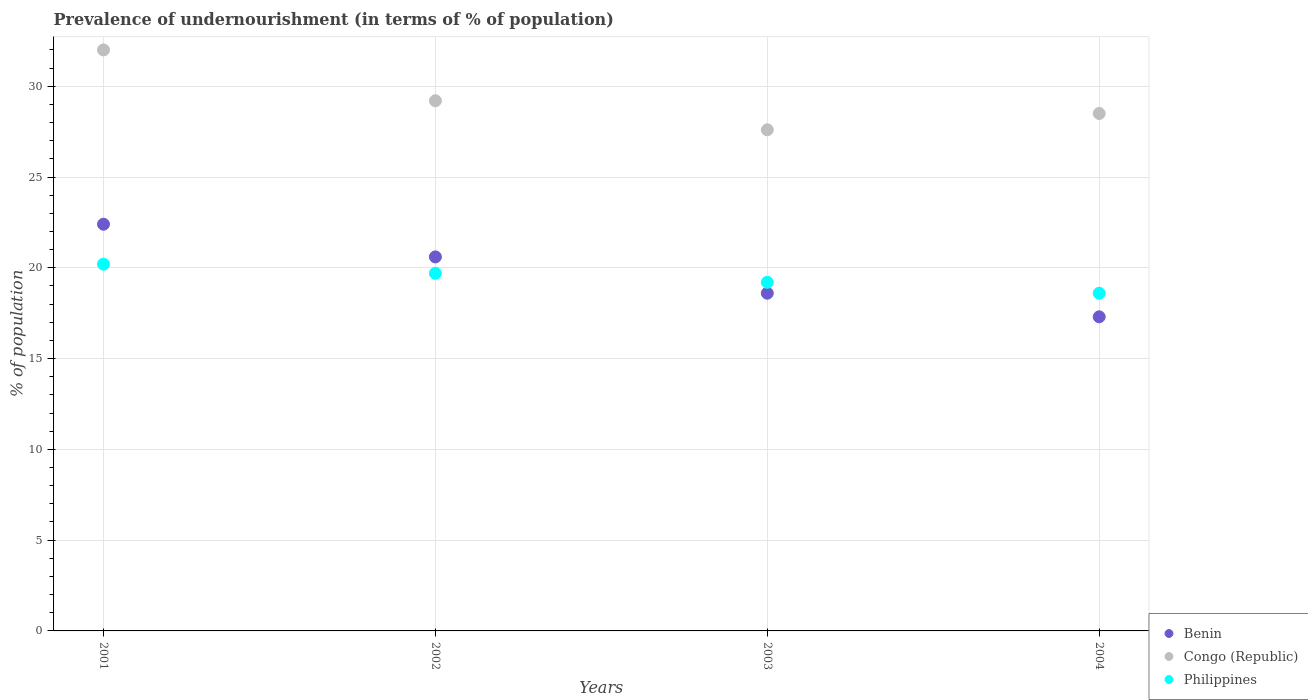What is the percentage of undernourished population in Benin in 2003?
Provide a short and direct response. 18.6. Across all years, what is the maximum percentage of undernourished population in Benin?
Offer a very short reply. 22.4. Across all years, what is the minimum percentage of undernourished population in Philippines?
Provide a short and direct response. 18.6. In which year was the percentage of undernourished population in Benin minimum?
Your answer should be very brief. 2004. What is the total percentage of undernourished population in Philippines in the graph?
Offer a terse response. 77.7. What is the difference between the percentage of undernourished population in Philippines in 2001 and that in 2003?
Ensure brevity in your answer.  1. What is the difference between the percentage of undernourished population in Benin in 2002 and the percentage of undernourished population in Congo (Republic) in 2001?
Your response must be concise. -11.4. What is the average percentage of undernourished population in Benin per year?
Your answer should be very brief. 19.73. In how many years, is the percentage of undernourished population in Congo (Republic) greater than 14 %?
Offer a terse response. 4. What is the ratio of the percentage of undernourished population in Congo (Republic) in 2001 to that in 2004?
Your answer should be compact. 1.12. Is the percentage of undernourished population in Benin in 2001 less than that in 2003?
Your answer should be very brief. No. Is the difference between the percentage of undernourished population in Benin in 2001 and 2004 greater than the difference between the percentage of undernourished population in Congo (Republic) in 2001 and 2004?
Offer a very short reply. Yes. What is the difference between the highest and the second highest percentage of undernourished population in Congo (Republic)?
Give a very brief answer. 2.8. What is the difference between the highest and the lowest percentage of undernourished population in Philippines?
Ensure brevity in your answer.  1.6. Is the sum of the percentage of undernourished population in Philippines in 2001 and 2004 greater than the maximum percentage of undernourished population in Congo (Republic) across all years?
Provide a short and direct response. Yes. Does the percentage of undernourished population in Congo (Republic) monotonically increase over the years?
Provide a succinct answer. No. Is the percentage of undernourished population in Congo (Republic) strictly less than the percentage of undernourished population in Benin over the years?
Offer a terse response. No. How many years are there in the graph?
Provide a succinct answer. 4. What is the difference between two consecutive major ticks on the Y-axis?
Your answer should be compact. 5. Are the values on the major ticks of Y-axis written in scientific E-notation?
Your response must be concise. No. Does the graph contain any zero values?
Your response must be concise. No. Where does the legend appear in the graph?
Give a very brief answer. Bottom right. How many legend labels are there?
Make the answer very short. 3. What is the title of the graph?
Keep it short and to the point. Prevalence of undernourishment (in terms of % of population). What is the label or title of the Y-axis?
Offer a terse response. % of population. What is the % of population of Benin in 2001?
Your answer should be very brief. 22.4. What is the % of population in Congo (Republic) in 2001?
Ensure brevity in your answer.  32. What is the % of population in Philippines in 2001?
Your answer should be very brief. 20.2. What is the % of population in Benin in 2002?
Offer a very short reply. 20.6. What is the % of population of Congo (Republic) in 2002?
Ensure brevity in your answer.  29.2. What is the % of population in Philippines in 2002?
Your answer should be very brief. 19.7. What is the % of population of Congo (Republic) in 2003?
Offer a very short reply. 27.6. What is the % of population of Benin in 2004?
Make the answer very short. 17.3. What is the % of population of Congo (Republic) in 2004?
Your answer should be compact. 28.5. Across all years, what is the maximum % of population of Benin?
Offer a terse response. 22.4. Across all years, what is the maximum % of population in Philippines?
Your answer should be very brief. 20.2. Across all years, what is the minimum % of population of Benin?
Provide a succinct answer. 17.3. Across all years, what is the minimum % of population in Congo (Republic)?
Give a very brief answer. 27.6. Across all years, what is the minimum % of population in Philippines?
Give a very brief answer. 18.6. What is the total % of population in Benin in the graph?
Your answer should be very brief. 78.9. What is the total % of population in Congo (Republic) in the graph?
Ensure brevity in your answer.  117.3. What is the total % of population of Philippines in the graph?
Ensure brevity in your answer.  77.7. What is the difference between the % of population of Benin in 2001 and that in 2002?
Make the answer very short. 1.8. What is the difference between the % of population in Congo (Republic) in 2001 and that in 2003?
Keep it short and to the point. 4.4. What is the difference between the % of population in Congo (Republic) in 2002 and that in 2003?
Provide a succinct answer. 1.6. What is the difference between the % of population of Philippines in 2002 and that in 2003?
Keep it short and to the point. 0.5. What is the difference between the % of population of Benin in 2002 and that in 2004?
Ensure brevity in your answer.  3.3. What is the difference between the % of population in Philippines in 2003 and that in 2004?
Offer a very short reply. 0.6. What is the difference between the % of population in Benin in 2001 and the % of population in Congo (Republic) in 2004?
Keep it short and to the point. -6.1. What is the difference between the % of population of Benin in 2001 and the % of population of Philippines in 2004?
Ensure brevity in your answer.  3.8. What is the difference between the % of population of Benin in 2002 and the % of population of Congo (Republic) in 2003?
Give a very brief answer. -7. What is the difference between the % of population in Benin in 2002 and the % of population in Philippines in 2003?
Keep it short and to the point. 1.4. What is the difference between the % of population of Benin in 2002 and the % of population of Congo (Republic) in 2004?
Give a very brief answer. -7.9. What is the difference between the % of population of Benin in 2002 and the % of population of Philippines in 2004?
Ensure brevity in your answer.  2. What is the difference between the % of population in Congo (Republic) in 2002 and the % of population in Philippines in 2004?
Keep it short and to the point. 10.6. What is the difference between the % of population of Benin in 2003 and the % of population of Congo (Republic) in 2004?
Your response must be concise. -9.9. What is the average % of population in Benin per year?
Your response must be concise. 19.73. What is the average % of population of Congo (Republic) per year?
Offer a terse response. 29.32. What is the average % of population in Philippines per year?
Keep it short and to the point. 19.43. In the year 2002, what is the difference between the % of population of Benin and % of population of Congo (Republic)?
Give a very brief answer. -8.6. In the year 2002, what is the difference between the % of population of Benin and % of population of Philippines?
Give a very brief answer. 0.9. In the year 2003, what is the difference between the % of population in Benin and % of population in Philippines?
Give a very brief answer. -0.6. In the year 2004, what is the difference between the % of population in Benin and % of population in Philippines?
Your response must be concise. -1.3. In the year 2004, what is the difference between the % of population of Congo (Republic) and % of population of Philippines?
Provide a succinct answer. 9.9. What is the ratio of the % of population in Benin in 2001 to that in 2002?
Ensure brevity in your answer.  1.09. What is the ratio of the % of population of Congo (Republic) in 2001 to that in 2002?
Provide a succinct answer. 1.1. What is the ratio of the % of population of Philippines in 2001 to that in 2002?
Keep it short and to the point. 1.03. What is the ratio of the % of population of Benin in 2001 to that in 2003?
Provide a succinct answer. 1.2. What is the ratio of the % of population of Congo (Republic) in 2001 to that in 2003?
Your answer should be very brief. 1.16. What is the ratio of the % of population of Philippines in 2001 to that in 2003?
Your response must be concise. 1.05. What is the ratio of the % of population of Benin in 2001 to that in 2004?
Offer a very short reply. 1.29. What is the ratio of the % of population in Congo (Republic) in 2001 to that in 2004?
Ensure brevity in your answer.  1.12. What is the ratio of the % of population in Philippines in 2001 to that in 2004?
Give a very brief answer. 1.09. What is the ratio of the % of population in Benin in 2002 to that in 2003?
Your response must be concise. 1.11. What is the ratio of the % of population of Congo (Republic) in 2002 to that in 2003?
Provide a succinct answer. 1.06. What is the ratio of the % of population of Benin in 2002 to that in 2004?
Provide a short and direct response. 1.19. What is the ratio of the % of population in Congo (Republic) in 2002 to that in 2004?
Your answer should be compact. 1.02. What is the ratio of the % of population of Philippines in 2002 to that in 2004?
Keep it short and to the point. 1.06. What is the ratio of the % of population in Benin in 2003 to that in 2004?
Provide a short and direct response. 1.08. What is the ratio of the % of population of Congo (Republic) in 2003 to that in 2004?
Make the answer very short. 0.97. What is the ratio of the % of population of Philippines in 2003 to that in 2004?
Make the answer very short. 1.03. What is the difference between the highest and the second highest % of population of Benin?
Your response must be concise. 1.8. What is the difference between the highest and the second highest % of population of Congo (Republic)?
Give a very brief answer. 2.8. What is the difference between the highest and the lowest % of population in Benin?
Make the answer very short. 5.1. 